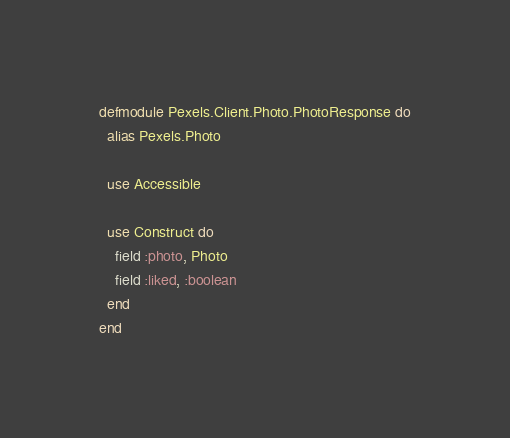Convert code to text. <code><loc_0><loc_0><loc_500><loc_500><_Elixir_>defmodule Pexels.Client.Photo.PhotoResponse do
  alias Pexels.Photo
  
  use Accessible

  use Construct do
    field :photo, Photo
    field :liked, :boolean
  end
end
</code> 